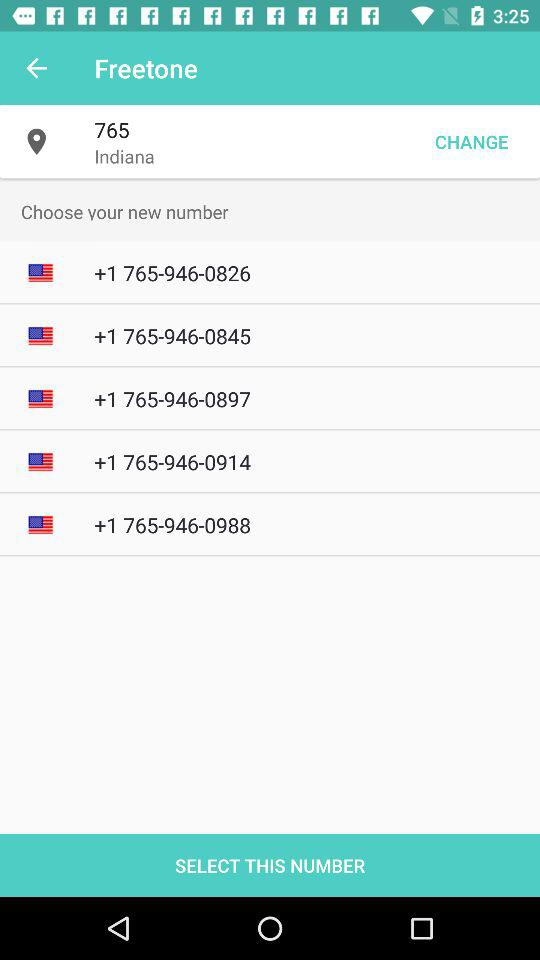How many numbers are available for selection?
Answer the question using a single word or phrase. 5 